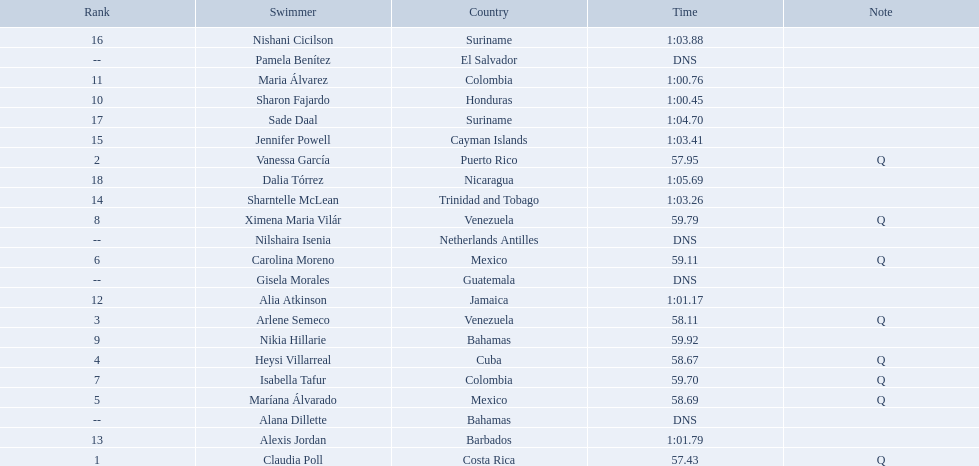Where were the top eight finishers from? Costa Rica, Puerto Rico, Venezuela, Cuba, Mexico, Mexico, Colombia, Venezuela. Which of the top eight were from cuba? Heysi Villarreal. 